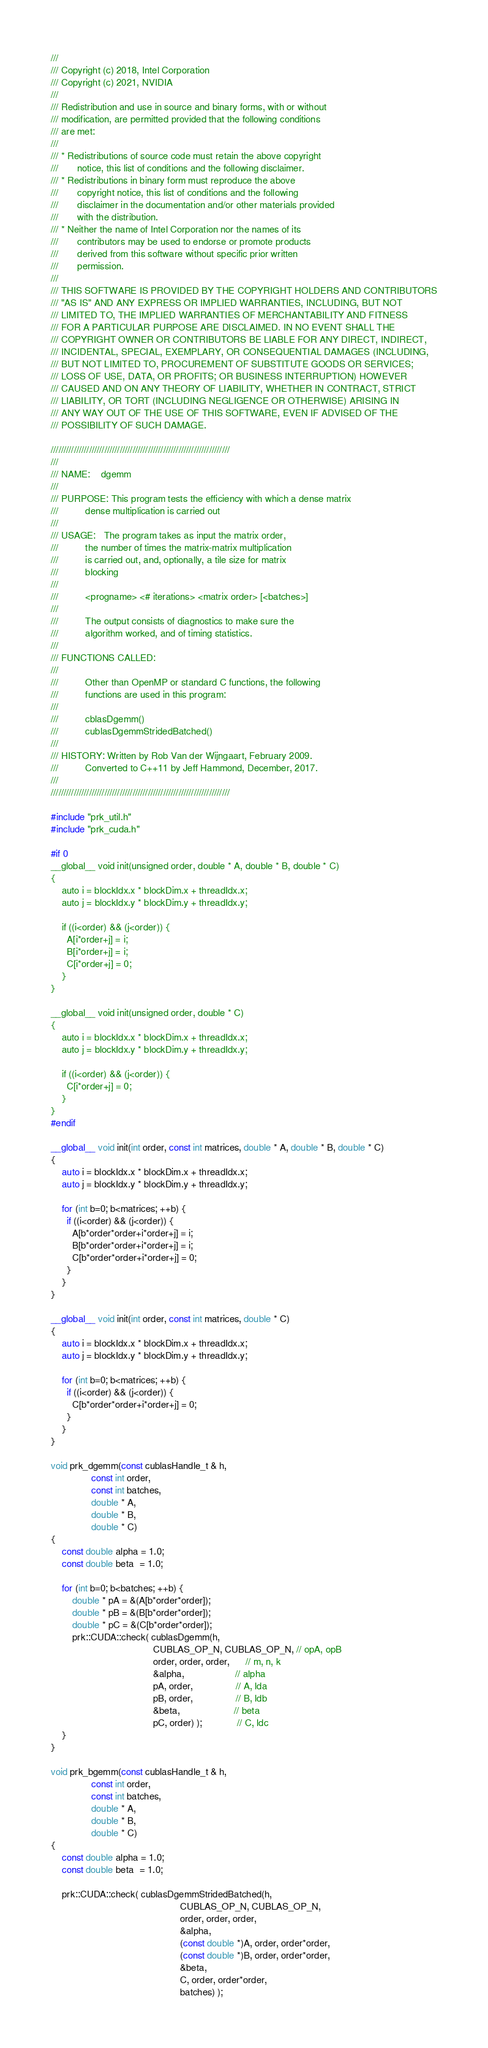<code> <loc_0><loc_0><loc_500><loc_500><_Cuda_>///
/// Copyright (c) 2018, Intel Corporation
/// Copyright (c) 2021, NVIDIA
///
/// Redistribution and use in source and binary forms, with or without
/// modification, are permitted provided that the following conditions
/// are met:
///
/// * Redistributions of source code must retain the above copyright
///       notice, this list of conditions and the following disclaimer.
/// * Redistributions in binary form must reproduce the above
///       copyright notice, this list of conditions and the following
///       disclaimer in the documentation and/or other materials provided
///       with the distribution.
/// * Neither the name of Intel Corporation nor the names of its
///       contributors may be used to endorse or promote products
///       derived from this software without specific prior written
///       permission.
///
/// THIS SOFTWARE IS PROVIDED BY THE COPYRIGHT HOLDERS AND CONTRIBUTORS
/// "AS IS" AND ANY EXPRESS OR IMPLIED WARRANTIES, INCLUDING, BUT NOT
/// LIMITED TO, THE IMPLIED WARRANTIES OF MERCHANTABILITY AND FITNESS
/// FOR A PARTICULAR PURPOSE ARE DISCLAIMED. IN NO EVENT SHALL THE
/// COPYRIGHT OWNER OR CONTRIBUTORS BE LIABLE FOR ANY DIRECT, INDIRECT,
/// INCIDENTAL, SPECIAL, EXEMPLARY, OR CONSEQUENTIAL DAMAGES (INCLUDING,
/// BUT NOT LIMITED TO, PROCUREMENT OF SUBSTITUTE GOODS OR SERVICES;
/// LOSS OF USE, DATA, OR PROFITS; OR BUSINESS INTERRUPTION) HOWEVER
/// CAUSED AND ON ANY THEORY OF LIABILITY, WHETHER IN CONTRACT, STRICT
/// LIABILITY, OR TORT (INCLUDING NEGLIGENCE OR OTHERWISE) ARISING IN
/// ANY WAY OUT OF THE USE OF THIS SOFTWARE, EVEN IF ADVISED OF THE
/// POSSIBILITY OF SUCH DAMAGE.

//////////////////////////////////////////////////////////////////////
///
/// NAME:    dgemm
///
/// PURPOSE: This program tests the efficiency with which a dense matrix
///          dense multiplication is carried out
///
/// USAGE:   The program takes as input the matrix order,
///          the number of times the matrix-matrix multiplication
///          is carried out, and, optionally, a tile size for matrix
///          blocking
///
///          <progname> <# iterations> <matrix order> [<batches>]
///
///          The output consists of diagnostics to make sure the
///          algorithm worked, and of timing statistics.
///
/// FUNCTIONS CALLED:
///
///          Other than OpenMP or standard C functions, the following
///          functions are used in this program:
///
///          cblasDgemm()
///          cublasDgemmStridedBatched()
///
/// HISTORY: Written by Rob Van der Wijngaart, February 2009.
///          Converted to C++11 by Jeff Hammond, December, 2017.
///
//////////////////////////////////////////////////////////////////////

#include "prk_util.h"
#include "prk_cuda.h"

#if 0
__global__ void init(unsigned order, double * A, double * B, double * C)
{
    auto i = blockIdx.x * blockDim.x + threadIdx.x;
    auto j = blockIdx.y * blockDim.y + threadIdx.y;

    if ((i<order) && (j<order)) {
      A[i*order+j] = i;
      B[i*order+j] = i;
      C[i*order+j] = 0;
    }
}

__global__ void init(unsigned order, double * C)
{
    auto i = blockIdx.x * blockDim.x + threadIdx.x;
    auto j = blockIdx.y * blockDim.y + threadIdx.y;

    if ((i<order) && (j<order)) {
      C[i*order+j] = 0;
    }
}
#endif

__global__ void init(int order, const int matrices, double * A, double * B, double * C)
{
    auto i = blockIdx.x * blockDim.x + threadIdx.x;
    auto j = blockIdx.y * blockDim.y + threadIdx.y;

    for (int b=0; b<matrices; ++b) {
      if ((i<order) && (j<order)) {
        A[b*order*order+i*order+j] = i;
        B[b*order*order+i*order+j] = i;
        C[b*order*order+i*order+j] = 0;
      }
    }
}

__global__ void init(int order, const int matrices, double * C)
{
    auto i = blockIdx.x * blockDim.x + threadIdx.x;
    auto j = blockIdx.y * blockDim.y + threadIdx.y;

    for (int b=0; b<matrices; ++b) {
      if ((i<order) && (j<order)) {
        C[b*order*order+i*order+j] = 0;
      }
    }
}

void prk_dgemm(const cublasHandle_t & h,
               const int order,
               const int batches,
               double * A,
               double * B,
               double * C)
{
    const double alpha = 1.0;
    const double beta  = 1.0;

    for (int b=0; b<batches; ++b) {
        double * pA = &(A[b*order*order]);
        double * pB = &(B[b*order*order]);
        double * pC = &(C[b*order*order]);
        prk::CUDA::check( cublasDgemm(h,
                                      CUBLAS_OP_N, CUBLAS_OP_N, // opA, opB
                                      order, order, order,      // m, n, k
                                      &alpha,                   // alpha
                                      pA, order,                // A, lda
                                      pB, order,                // B, ldb
                                      &beta,                    // beta
                                      pC, order) );             // C, ldc
    }
}

void prk_bgemm(const cublasHandle_t & h,
               const int order,
               const int batches,
               double * A,
               double * B,
               double * C)
{
    const double alpha = 1.0;
    const double beta  = 1.0;

    prk::CUDA::check( cublasDgemmStridedBatched(h,
                                                CUBLAS_OP_N, CUBLAS_OP_N,
                                                order, order, order,
                                                &alpha,
                                                (const double *)A, order, order*order,
                                                (const double *)B, order, order*order,
                                                &beta,
                                                C, order, order*order,
                                                batches) );
</code> 